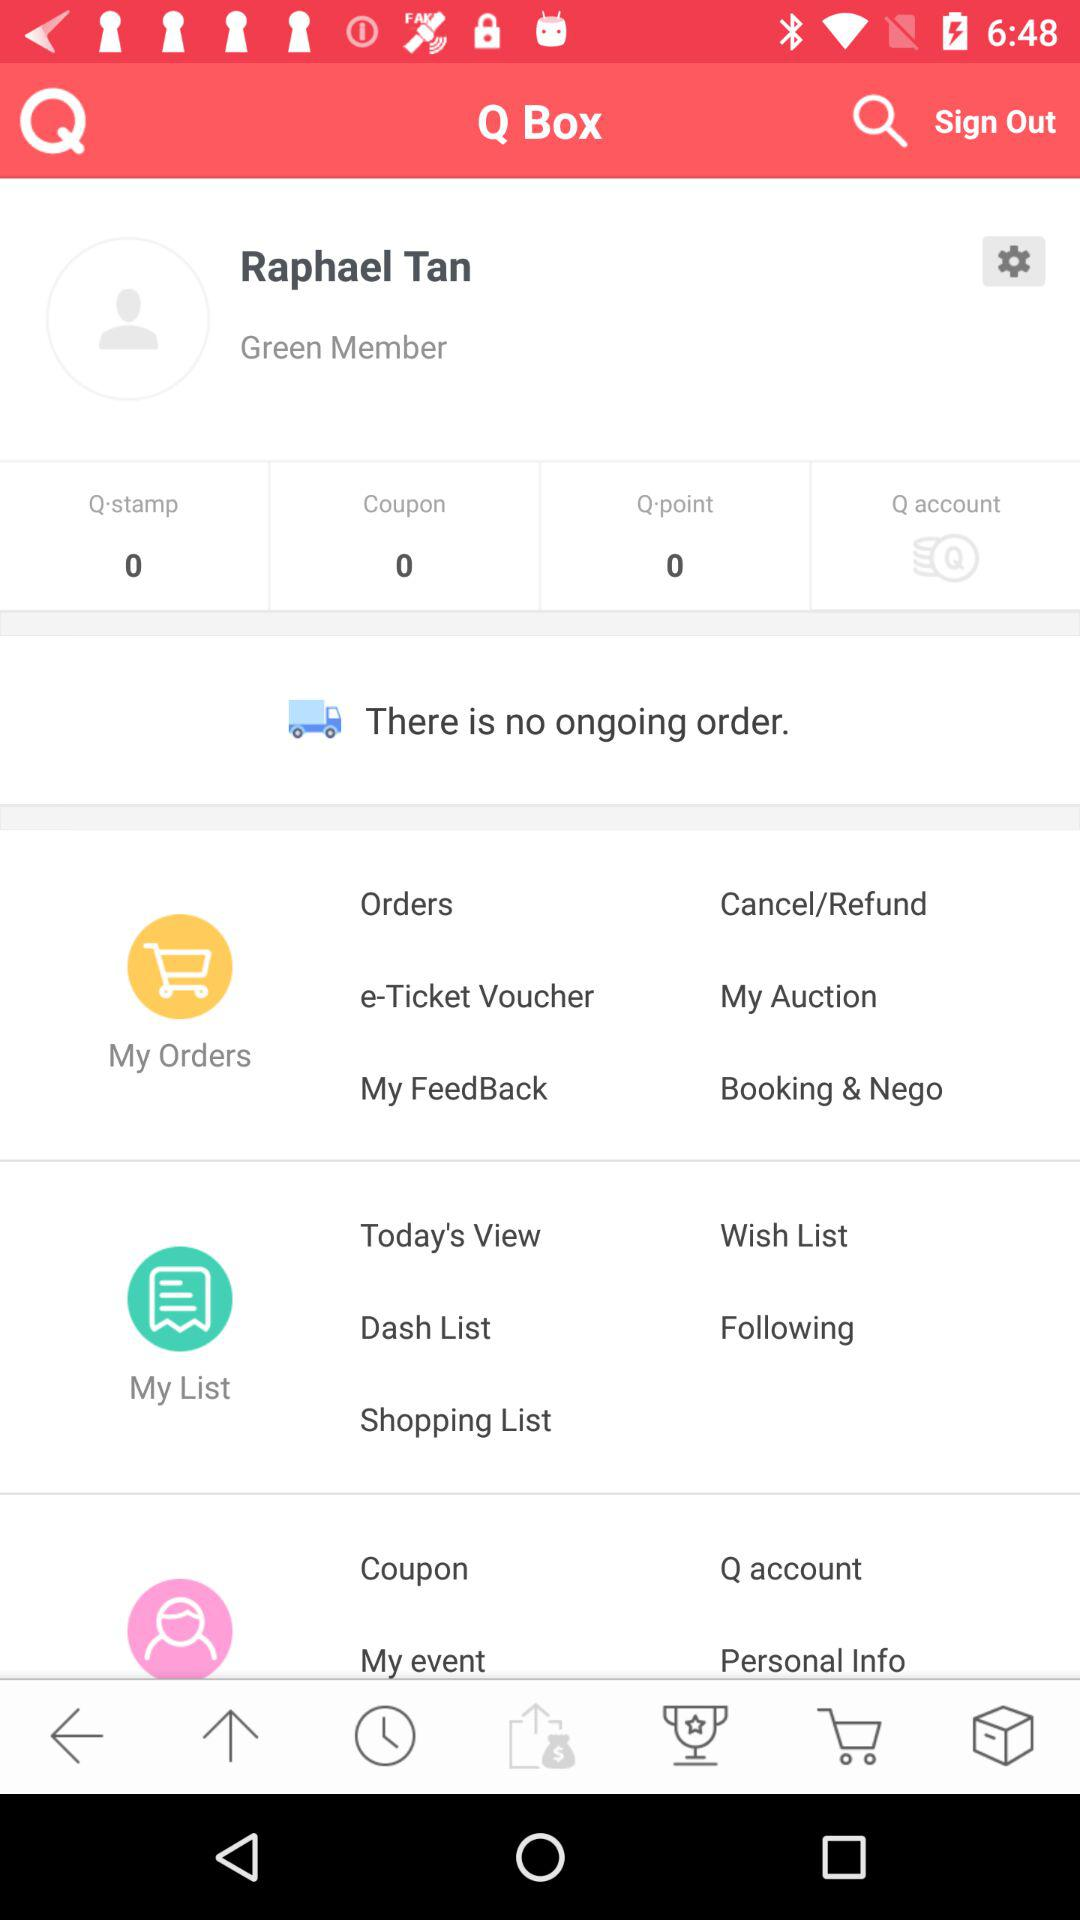What is the user name? The user name is Raphael Tan. 